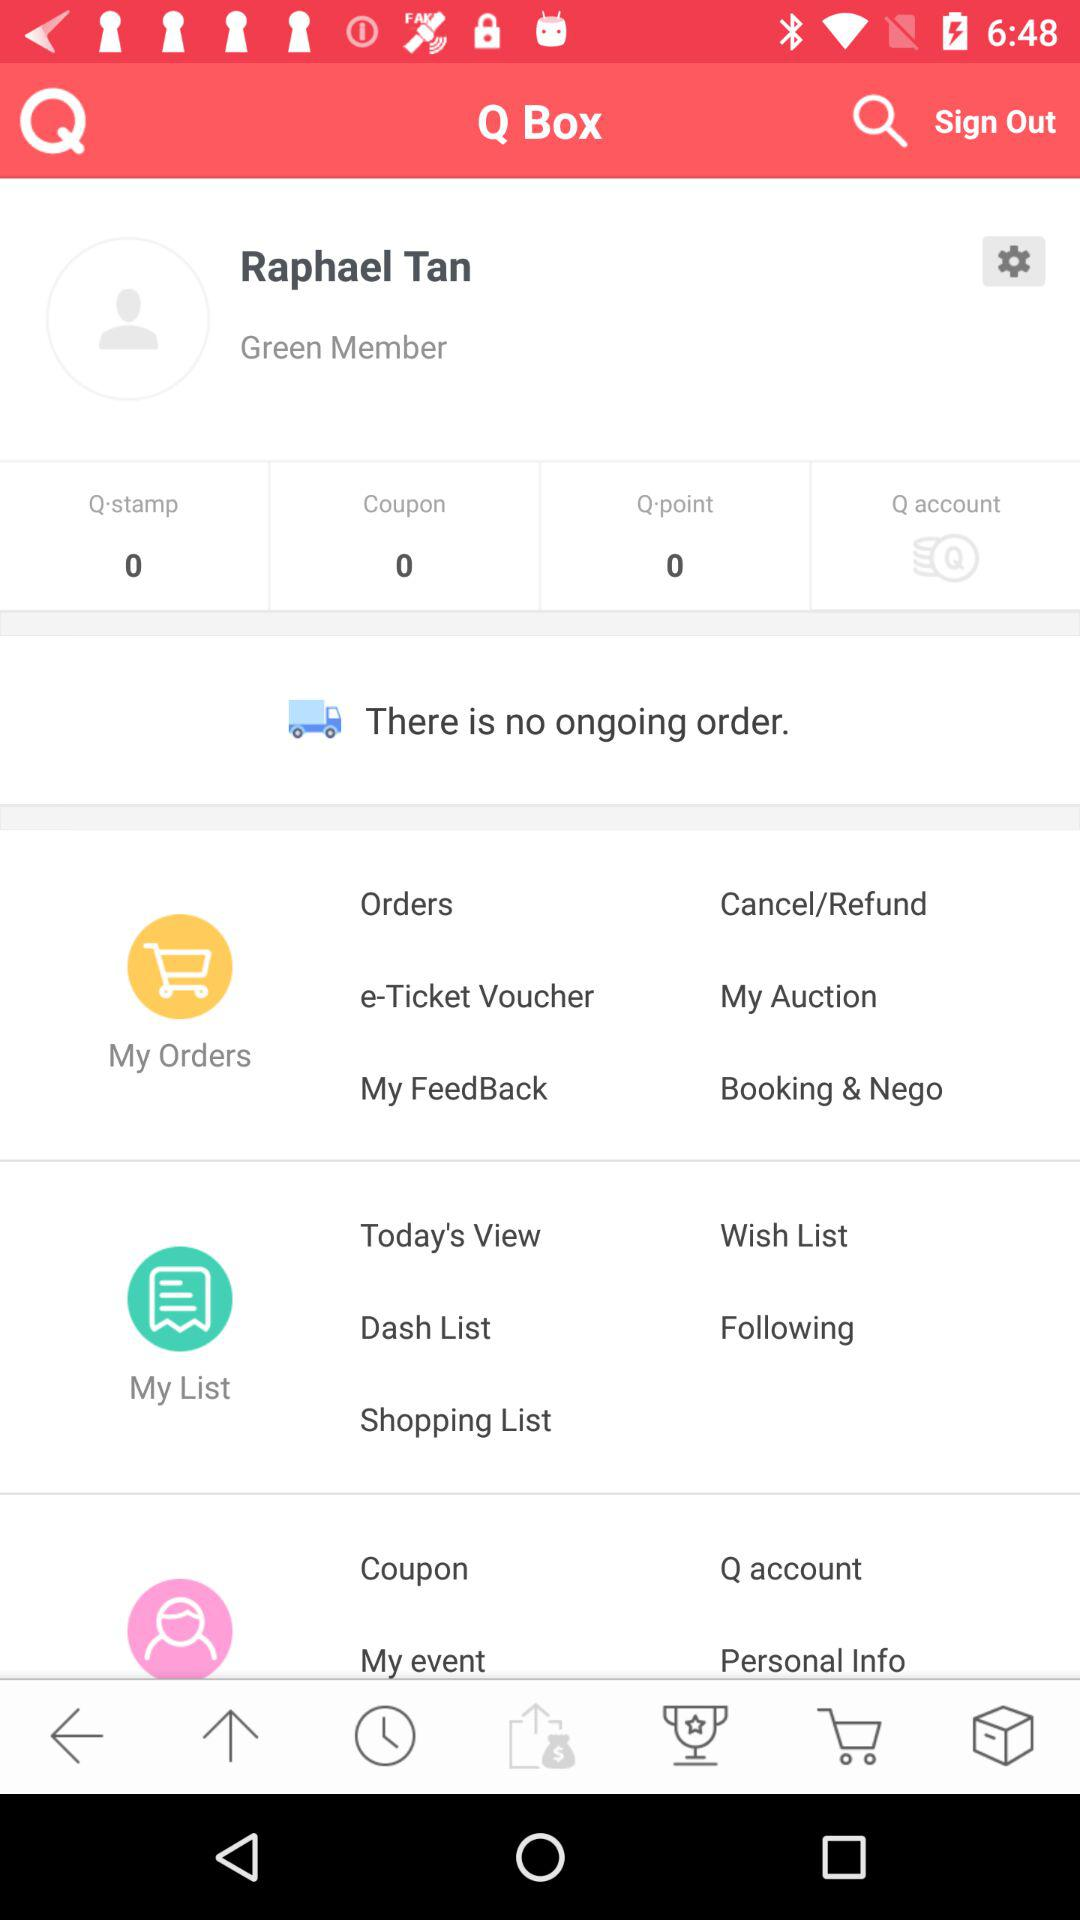What is the user name? The user name is Raphael Tan. 